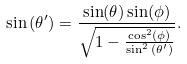<formula> <loc_0><loc_0><loc_500><loc_500>\sin { ( \theta ^ { \prime } ) } = \frac { \sin ( \theta ) \sin ( \phi ) } { \sqrt { 1 - \frac { \cos ^ { 2 } ( \phi ) } { \sin ^ { 2 } { ( \theta ^ { \prime } ) } } } } .</formula> 